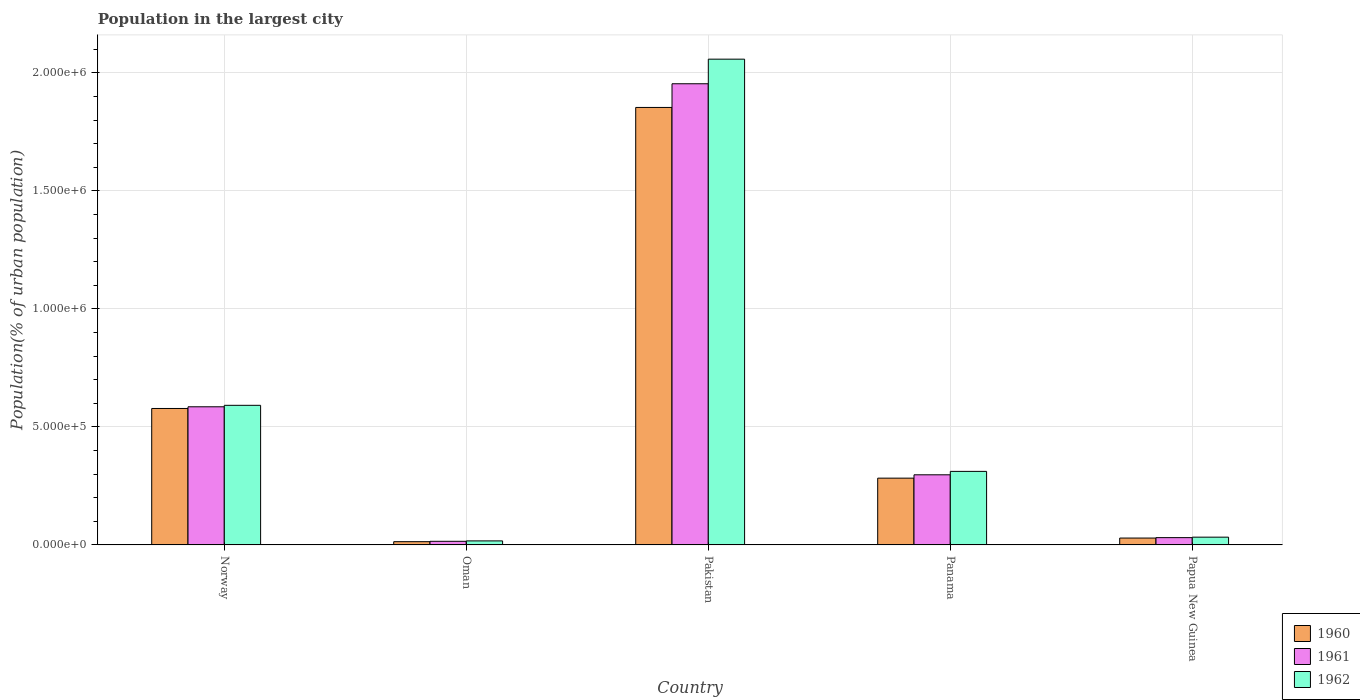Are the number of bars per tick equal to the number of legend labels?
Provide a succinct answer. Yes. How many bars are there on the 5th tick from the right?
Give a very brief answer. 3. What is the label of the 2nd group of bars from the left?
Offer a terse response. Oman. In how many cases, is the number of bars for a given country not equal to the number of legend labels?
Your answer should be very brief. 0. What is the population in the largest city in 1961 in Norway?
Make the answer very short. 5.85e+05. Across all countries, what is the maximum population in the largest city in 1962?
Offer a terse response. 2.06e+06. Across all countries, what is the minimum population in the largest city in 1960?
Provide a succinct answer. 1.38e+04. In which country was the population in the largest city in 1962 minimum?
Make the answer very short. Oman. What is the total population in the largest city in 1962 in the graph?
Ensure brevity in your answer.  3.01e+06. What is the difference between the population in the largest city in 1961 in Oman and that in Panama?
Provide a short and direct response. -2.82e+05. What is the difference between the population in the largest city in 1962 in Oman and the population in the largest city in 1960 in Pakistan?
Offer a very short reply. -1.84e+06. What is the average population in the largest city in 1960 per country?
Provide a short and direct response. 5.51e+05. What is the difference between the population in the largest city of/in 1962 and population in the largest city of/in 1960 in Papua New Guinea?
Your answer should be very brief. 3820. In how many countries, is the population in the largest city in 1960 greater than 200000 %?
Give a very brief answer. 3. What is the ratio of the population in the largest city in 1961 in Oman to that in Panama?
Keep it short and to the point. 0.05. Is the difference between the population in the largest city in 1962 in Oman and Pakistan greater than the difference between the population in the largest city in 1960 in Oman and Pakistan?
Keep it short and to the point. No. What is the difference between the highest and the second highest population in the largest city in 1962?
Your answer should be very brief. 1.75e+06. What is the difference between the highest and the lowest population in the largest city in 1960?
Provide a succinct answer. 1.84e+06. What does the 1st bar from the right in Panama represents?
Offer a very short reply. 1962. Is it the case that in every country, the sum of the population in the largest city in 1961 and population in the largest city in 1962 is greater than the population in the largest city in 1960?
Provide a short and direct response. Yes. What is the difference between two consecutive major ticks on the Y-axis?
Offer a very short reply. 5.00e+05. Does the graph contain grids?
Ensure brevity in your answer.  Yes. What is the title of the graph?
Provide a succinct answer. Population in the largest city. Does "1980" appear as one of the legend labels in the graph?
Your answer should be very brief. No. What is the label or title of the X-axis?
Give a very brief answer. Country. What is the label or title of the Y-axis?
Offer a very short reply. Population(% of urban population). What is the Population(% of urban population) in 1960 in Norway?
Give a very brief answer. 5.78e+05. What is the Population(% of urban population) in 1961 in Norway?
Your response must be concise. 5.85e+05. What is the Population(% of urban population) in 1962 in Norway?
Offer a terse response. 5.91e+05. What is the Population(% of urban population) of 1960 in Oman?
Your answer should be compact. 1.38e+04. What is the Population(% of urban population) of 1961 in Oman?
Keep it short and to the point. 1.54e+04. What is the Population(% of urban population) of 1962 in Oman?
Ensure brevity in your answer.  1.71e+04. What is the Population(% of urban population) of 1960 in Pakistan?
Offer a very short reply. 1.85e+06. What is the Population(% of urban population) in 1961 in Pakistan?
Offer a very short reply. 1.95e+06. What is the Population(% of urban population) in 1962 in Pakistan?
Offer a very short reply. 2.06e+06. What is the Population(% of urban population) in 1960 in Panama?
Offer a very short reply. 2.83e+05. What is the Population(% of urban population) in 1961 in Panama?
Your answer should be very brief. 2.97e+05. What is the Population(% of urban population) of 1962 in Panama?
Your answer should be compact. 3.12e+05. What is the Population(% of urban population) of 1960 in Papua New Guinea?
Offer a very short reply. 2.91e+04. What is the Population(% of urban population) of 1961 in Papua New Guinea?
Keep it short and to the point. 3.10e+04. What is the Population(% of urban population) in 1962 in Papua New Guinea?
Offer a terse response. 3.29e+04. Across all countries, what is the maximum Population(% of urban population) of 1960?
Ensure brevity in your answer.  1.85e+06. Across all countries, what is the maximum Population(% of urban population) in 1961?
Provide a succinct answer. 1.95e+06. Across all countries, what is the maximum Population(% of urban population) of 1962?
Ensure brevity in your answer.  2.06e+06. Across all countries, what is the minimum Population(% of urban population) of 1960?
Provide a short and direct response. 1.38e+04. Across all countries, what is the minimum Population(% of urban population) in 1961?
Provide a short and direct response. 1.54e+04. Across all countries, what is the minimum Population(% of urban population) of 1962?
Keep it short and to the point. 1.71e+04. What is the total Population(% of urban population) in 1960 in the graph?
Provide a succinct answer. 2.76e+06. What is the total Population(% of urban population) in 1961 in the graph?
Provide a succinct answer. 2.88e+06. What is the total Population(% of urban population) in 1962 in the graph?
Offer a terse response. 3.01e+06. What is the difference between the Population(% of urban population) in 1960 in Norway and that in Oman?
Keep it short and to the point. 5.64e+05. What is the difference between the Population(% of urban population) in 1961 in Norway and that in Oman?
Your answer should be compact. 5.70e+05. What is the difference between the Population(% of urban population) in 1962 in Norway and that in Oman?
Provide a succinct answer. 5.74e+05. What is the difference between the Population(% of urban population) of 1960 in Norway and that in Pakistan?
Provide a short and direct response. -1.28e+06. What is the difference between the Population(% of urban population) of 1961 in Norway and that in Pakistan?
Make the answer very short. -1.37e+06. What is the difference between the Population(% of urban population) in 1962 in Norway and that in Pakistan?
Your answer should be compact. -1.47e+06. What is the difference between the Population(% of urban population) in 1960 in Norway and that in Panama?
Keep it short and to the point. 2.95e+05. What is the difference between the Population(% of urban population) of 1961 in Norway and that in Panama?
Keep it short and to the point. 2.88e+05. What is the difference between the Population(% of urban population) of 1962 in Norway and that in Panama?
Make the answer very short. 2.80e+05. What is the difference between the Population(% of urban population) in 1960 in Norway and that in Papua New Guinea?
Provide a short and direct response. 5.49e+05. What is the difference between the Population(% of urban population) in 1961 in Norway and that in Papua New Guinea?
Provide a short and direct response. 5.54e+05. What is the difference between the Population(% of urban population) in 1962 in Norway and that in Papua New Guinea?
Offer a very short reply. 5.58e+05. What is the difference between the Population(% of urban population) of 1960 in Oman and that in Pakistan?
Ensure brevity in your answer.  -1.84e+06. What is the difference between the Population(% of urban population) in 1961 in Oman and that in Pakistan?
Provide a short and direct response. -1.94e+06. What is the difference between the Population(% of urban population) of 1962 in Oman and that in Pakistan?
Make the answer very short. -2.04e+06. What is the difference between the Population(% of urban population) of 1960 in Oman and that in Panama?
Give a very brief answer. -2.69e+05. What is the difference between the Population(% of urban population) in 1961 in Oman and that in Panama?
Offer a very short reply. -2.82e+05. What is the difference between the Population(% of urban population) of 1962 in Oman and that in Panama?
Make the answer very short. -2.94e+05. What is the difference between the Population(% of urban population) of 1960 in Oman and that in Papua New Guinea?
Provide a short and direct response. -1.53e+04. What is the difference between the Population(% of urban population) in 1961 in Oman and that in Papua New Guinea?
Your response must be concise. -1.56e+04. What is the difference between the Population(% of urban population) of 1962 in Oman and that in Papua New Guinea?
Ensure brevity in your answer.  -1.58e+04. What is the difference between the Population(% of urban population) in 1960 in Pakistan and that in Panama?
Give a very brief answer. 1.57e+06. What is the difference between the Population(% of urban population) of 1961 in Pakistan and that in Panama?
Keep it short and to the point. 1.66e+06. What is the difference between the Population(% of urban population) of 1962 in Pakistan and that in Panama?
Provide a succinct answer. 1.75e+06. What is the difference between the Population(% of urban population) of 1960 in Pakistan and that in Papua New Guinea?
Your answer should be compact. 1.82e+06. What is the difference between the Population(% of urban population) in 1961 in Pakistan and that in Papua New Guinea?
Your answer should be compact. 1.92e+06. What is the difference between the Population(% of urban population) in 1962 in Pakistan and that in Papua New Guinea?
Provide a succinct answer. 2.02e+06. What is the difference between the Population(% of urban population) in 1960 in Panama and that in Papua New Guinea?
Keep it short and to the point. 2.54e+05. What is the difference between the Population(% of urban population) of 1961 in Panama and that in Papua New Guinea?
Offer a very short reply. 2.66e+05. What is the difference between the Population(% of urban population) of 1962 in Panama and that in Papua New Guinea?
Ensure brevity in your answer.  2.79e+05. What is the difference between the Population(% of urban population) of 1960 in Norway and the Population(% of urban population) of 1961 in Oman?
Your response must be concise. 5.63e+05. What is the difference between the Population(% of urban population) in 1960 in Norway and the Population(% of urban population) in 1962 in Oman?
Your answer should be very brief. 5.61e+05. What is the difference between the Population(% of urban population) of 1961 in Norway and the Population(% of urban population) of 1962 in Oman?
Your answer should be very brief. 5.68e+05. What is the difference between the Population(% of urban population) of 1960 in Norway and the Population(% of urban population) of 1961 in Pakistan?
Give a very brief answer. -1.38e+06. What is the difference between the Population(% of urban population) in 1960 in Norway and the Population(% of urban population) in 1962 in Pakistan?
Ensure brevity in your answer.  -1.48e+06. What is the difference between the Population(% of urban population) in 1961 in Norway and the Population(% of urban population) in 1962 in Pakistan?
Your response must be concise. -1.47e+06. What is the difference between the Population(% of urban population) in 1960 in Norway and the Population(% of urban population) in 1961 in Panama?
Your response must be concise. 2.81e+05. What is the difference between the Population(% of urban population) in 1960 in Norway and the Population(% of urban population) in 1962 in Panama?
Ensure brevity in your answer.  2.66e+05. What is the difference between the Population(% of urban population) in 1961 in Norway and the Population(% of urban population) in 1962 in Panama?
Your answer should be very brief. 2.74e+05. What is the difference between the Population(% of urban population) of 1960 in Norway and the Population(% of urban population) of 1961 in Papua New Guinea?
Your answer should be compact. 5.47e+05. What is the difference between the Population(% of urban population) in 1960 in Norway and the Population(% of urban population) in 1962 in Papua New Guinea?
Make the answer very short. 5.45e+05. What is the difference between the Population(% of urban population) in 1961 in Norway and the Population(% of urban population) in 1962 in Papua New Guinea?
Offer a terse response. 5.52e+05. What is the difference between the Population(% of urban population) of 1960 in Oman and the Population(% of urban population) of 1961 in Pakistan?
Offer a terse response. -1.94e+06. What is the difference between the Population(% of urban population) of 1960 in Oman and the Population(% of urban population) of 1962 in Pakistan?
Your answer should be very brief. -2.04e+06. What is the difference between the Population(% of urban population) of 1961 in Oman and the Population(% of urban population) of 1962 in Pakistan?
Your answer should be compact. -2.04e+06. What is the difference between the Population(% of urban population) in 1960 in Oman and the Population(% of urban population) in 1961 in Panama?
Keep it short and to the point. -2.83e+05. What is the difference between the Population(% of urban population) in 1960 in Oman and the Population(% of urban population) in 1962 in Panama?
Offer a very short reply. -2.98e+05. What is the difference between the Population(% of urban population) of 1961 in Oman and the Population(% of urban population) of 1962 in Panama?
Your response must be concise. -2.96e+05. What is the difference between the Population(% of urban population) of 1960 in Oman and the Population(% of urban population) of 1961 in Papua New Guinea?
Keep it short and to the point. -1.72e+04. What is the difference between the Population(% of urban population) of 1960 in Oman and the Population(% of urban population) of 1962 in Papua New Guinea?
Your answer should be compact. -1.91e+04. What is the difference between the Population(% of urban population) of 1961 in Oman and the Population(% of urban population) of 1962 in Papua New Guinea?
Your response must be concise. -1.76e+04. What is the difference between the Population(% of urban population) of 1960 in Pakistan and the Population(% of urban population) of 1961 in Panama?
Offer a very short reply. 1.56e+06. What is the difference between the Population(% of urban population) in 1960 in Pakistan and the Population(% of urban population) in 1962 in Panama?
Offer a terse response. 1.54e+06. What is the difference between the Population(% of urban population) in 1961 in Pakistan and the Population(% of urban population) in 1962 in Panama?
Offer a very short reply. 1.64e+06. What is the difference between the Population(% of urban population) of 1960 in Pakistan and the Population(% of urban population) of 1961 in Papua New Guinea?
Provide a succinct answer. 1.82e+06. What is the difference between the Population(% of urban population) of 1960 in Pakistan and the Population(% of urban population) of 1962 in Papua New Guinea?
Offer a very short reply. 1.82e+06. What is the difference between the Population(% of urban population) in 1961 in Pakistan and the Population(% of urban population) in 1962 in Papua New Guinea?
Offer a very short reply. 1.92e+06. What is the difference between the Population(% of urban population) in 1960 in Panama and the Population(% of urban population) in 1961 in Papua New Guinea?
Your response must be concise. 2.52e+05. What is the difference between the Population(% of urban population) in 1960 in Panama and the Population(% of urban population) in 1962 in Papua New Guinea?
Offer a terse response. 2.50e+05. What is the difference between the Population(% of urban population) in 1961 in Panama and the Population(% of urban population) in 1962 in Papua New Guinea?
Ensure brevity in your answer.  2.64e+05. What is the average Population(% of urban population) of 1960 per country?
Provide a short and direct response. 5.51e+05. What is the average Population(% of urban population) in 1961 per country?
Give a very brief answer. 5.76e+05. What is the average Population(% of urban population) of 1962 per country?
Keep it short and to the point. 6.02e+05. What is the difference between the Population(% of urban population) in 1960 and Population(% of urban population) in 1961 in Norway?
Offer a very short reply. -7186. What is the difference between the Population(% of urban population) of 1960 and Population(% of urban population) of 1962 in Norway?
Your response must be concise. -1.34e+04. What is the difference between the Population(% of urban population) of 1961 and Population(% of urban population) of 1962 in Norway?
Give a very brief answer. -6168. What is the difference between the Population(% of urban population) in 1960 and Population(% of urban population) in 1961 in Oman?
Your answer should be compact. -1572. What is the difference between the Population(% of urban population) of 1960 and Population(% of urban population) of 1962 in Oman?
Offer a terse response. -3326. What is the difference between the Population(% of urban population) of 1961 and Population(% of urban population) of 1962 in Oman?
Offer a very short reply. -1754. What is the difference between the Population(% of urban population) of 1960 and Population(% of urban population) of 1961 in Pakistan?
Give a very brief answer. -1.00e+05. What is the difference between the Population(% of urban population) in 1960 and Population(% of urban population) in 1962 in Pakistan?
Offer a very short reply. -2.05e+05. What is the difference between the Population(% of urban population) of 1961 and Population(% of urban population) of 1962 in Pakistan?
Your answer should be compact. -1.04e+05. What is the difference between the Population(% of urban population) of 1960 and Population(% of urban population) of 1961 in Panama?
Make the answer very short. -1.42e+04. What is the difference between the Population(% of urban population) in 1960 and Population(% of urban population) in 1962 in Panama?
Offer a very short reply. -2.87e+04. What is the difference between the Population(% of urban population) in 1961 and Population(% of urban population) in 1962 in Panama?
Your answer should be compact. -1.45e+04. What is the difference between the Population(% of urban population) in 1960 and Population(% of urban population) in 1961 in Papua New Guinea?
Your answer should be compact. -1850. What is the difference between the Population(% of urban population) in 1960 and Population(% of urban population) in 1962 in Papua New Guinea?
Keep it short and to the point. -3820. What is the difference between the Population(% of urban population) in 1961 and Population(% of urban population) in 1962 in Papua New Guinea?
Ensure brevity in your answer.  -1970. What is the ratio of the Population(% of urban population) in 1960 in Norway to that in Oman?
Ensure brevity in your answer.  41.91. What is the ratio of the Population(% of urban population) of 1961 in Norway to that in Oman?
Offer a terse response. 38.09. What is the ratio of the Population(% of urban population) in 1962 in Norway to that in Oman?
Provide a short and direct response. 34.55. What is the ratio of the Population(% of urban population) in 1960 in Norway to that in Pakistan?
Make the answer very short. 0.31. What is the ratio of the Population(% of urban population) in 1961 in Norway to that in Pakistan?
Your response must be concise. 0.3. What is the ratio of the Population(% of urban population) in 1962 in Norway to that in Pakistan?
Keep it short and to the point. 0.29. What is the ratio of the Population(% of urban population) of 1960 in Norway to that in Panama?
Ensure brevity in your answer.  2.04. What is the ratio of the Population(% of urban population) in 1961 in Norway to that in Panama?
Provide a succinct answer. 1.97. What is the ratio of the Population(% of urban population) of 1962 in Norway to that in Panama?
Your answer should be compact. 1.9. What is the ratio of the Population(% of urban population) in 1960 in Norway to that in Papua New Guinea?
Make the answer very short. 19.86. What is the ratio of the Population(% of urban population) in 1961 in Norway to that in Papua New Guinea?
Offer a terse response. 18.91. What is the ratio of the Population(% of urban population) in 1962 in Norway to that in Papua New Guinea?
Your response must be concise. 17.96. What is the ratio of the Population(% of urban population) in 1960 in Oman to that in Pakistan?
Your response must be concise. 0.01. What is the ratio of the Population(% of urban population) in 1961 in Oman to that in Pakistan?
Your answer should be compact. 0.01. What is the ratio of the Population(% of urban population) of 1962 in Oman to that in Pakistan?
Keep it short and to the point. 0.01. What is the ratio of the Population(% of urban population) in 1960 in Oman to that in Panama?
Provide a short and direct response. 0.05. What is the ratio of the Population(% of urban population) in 1961 in Oman to that in Panama?
Provide a short and direct response. 0.05. What is the ratio of the Population(% of urban population) in 1962 in Oman to that in Panama?
Your answer should be very brief. 0.05. What is the ratio of the Population(% of urban population) of 1960 in Oman to that in Papua New Guinea?
Your response must be concise. 0.47. What is the ratio of the Population(% of urban population) of 1961 in Oman to that in Papua New Guinea?
Ensure brevity in your answer.  0.5. What is the ratio of the Population(% of urban population) in 1962 in Oman to that in Papua New Guinea?
Ensure brevity in your answer.  0.52. What is the ratio of the Population(% of urban population) of 1960 in Pakistan to that in Panama?
Your response must be concise. 6.55. What is the ratio of the Population(% of urban population) in 1961 in Pakistan to that in Panama?
Give a very brief answer. 6.58. What is the ratio of the Population(% of urban population) in 1962 in Pakistan to that in Panama?
Give a very brief answer. 6.6. What is the ratio of the Population(% of urban population) in 1960 in Pakistan to that in Papua New Guinea?
Make the answer very short. 63.68. What is the ratio of the Population(% of urban population) in 1961 in Pakistan to that in Papua New Guinea?
Give a very brief answer. 63.12. What is the ratio of the Population(% of urban population) of 1962 in Pakistan to that in Papua New Guinea?
Your answer should be very brief. 62.5. What is the ratio of the Population(% of urban population) of 1960 in Panama to that in Papua New Guinea?
Give a very brief answer. 9.72. What is the ratio of the Population(% of urban population) in 1961 in Panama to that in Papua New Guinea?
Your answer should be compact. 9.6. What is the ratio of the Population(% of urban population) in 1962 in Panama to that in Papua New Guinea?
Provide a succinct answer. 9.46. What is the difference between the highest and the second highest Population(% of urban population) in 1960?
Your answer should be compact. 1.28e+06. What is the difference between the highest and the second highest Population(% of urban population) of 1961?
Your answer should be compact. 1.37e+06. What is the difference between the highest and the second highest Population(% of urban population) in 1962?
Provide a succinct answer. 1.47e+06. What is the difference between the highest and the lowest Population(% of urban population) of 1960?
Make the answer very short. 1.84e+06. What is the difference between the highest and the lowest Population(% of urban population) in 1961?
Your response must be concise. 1.94e+06. What is the difference between the highest and the lowest Population(% of urban population) in 1962?
Your answer should be very brief. 2.04e+06. 